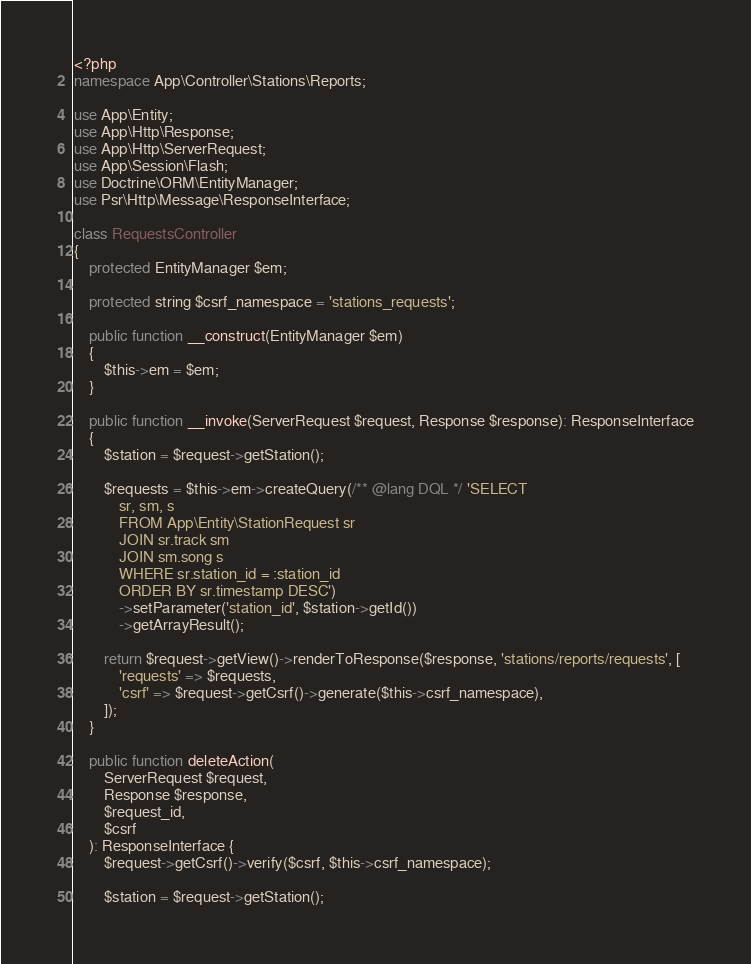Convert code to text. <code><loc_0><loc_0><loc_500><loc_500><_PHP_><?php
namespace App\Controller\Stations\Reports;

use App\Entity;
use App\Http\Response;
use App\Http\ServerRequest;
use App\Session\Flash;
use Doctrine\ORM\EntityManager;
use Psr\Http\Message\ResponseInterface;

class RequestsController
{
    protected EntityManager $em;

    protected string $csrf_namespace = 'stations_requests';

    public function __construct(EntityManager $em)
    {
        $this->em = $em;
    }

    public function __invoke(ServerRequest $request, Response $response): ResponseInterface
    {
        $station = $request->getStation();

        $requests = $this->em->createQuery(/** @lang DQL */ 'SELECT 
            sr, sm, s 
            FROM App\Entity\StationRequest sr
            JOIN sr.track sm
            JOIN sm.song s
            WHERE sr.station_id = :station_id
            ORDER BY sr.timestamp DESC')
            ->setParameter('station_id', $station->getId())
            ->getArrayResult();

        return $request->getView()->renderToResponse($response, 'stations/reports/requests', [
            'requests' => $requests,
            'csrf' => $request->getCsrf()->generate($this->csrf_namespace),
        ]);
    }

    public function deleteAction(
        ServerRequest $request,
        Response $response,
        $request_id,
        $csrf
    ): ResponseInterface {
        $request->getCsrf()->verify($csrf, $this->csrf_namespace);

        $station = $request->getStation();
</code> 